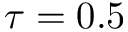<formula> <loc_0><loc_0><loc_500><loc_500>\tau = 0 . 5</formula> 